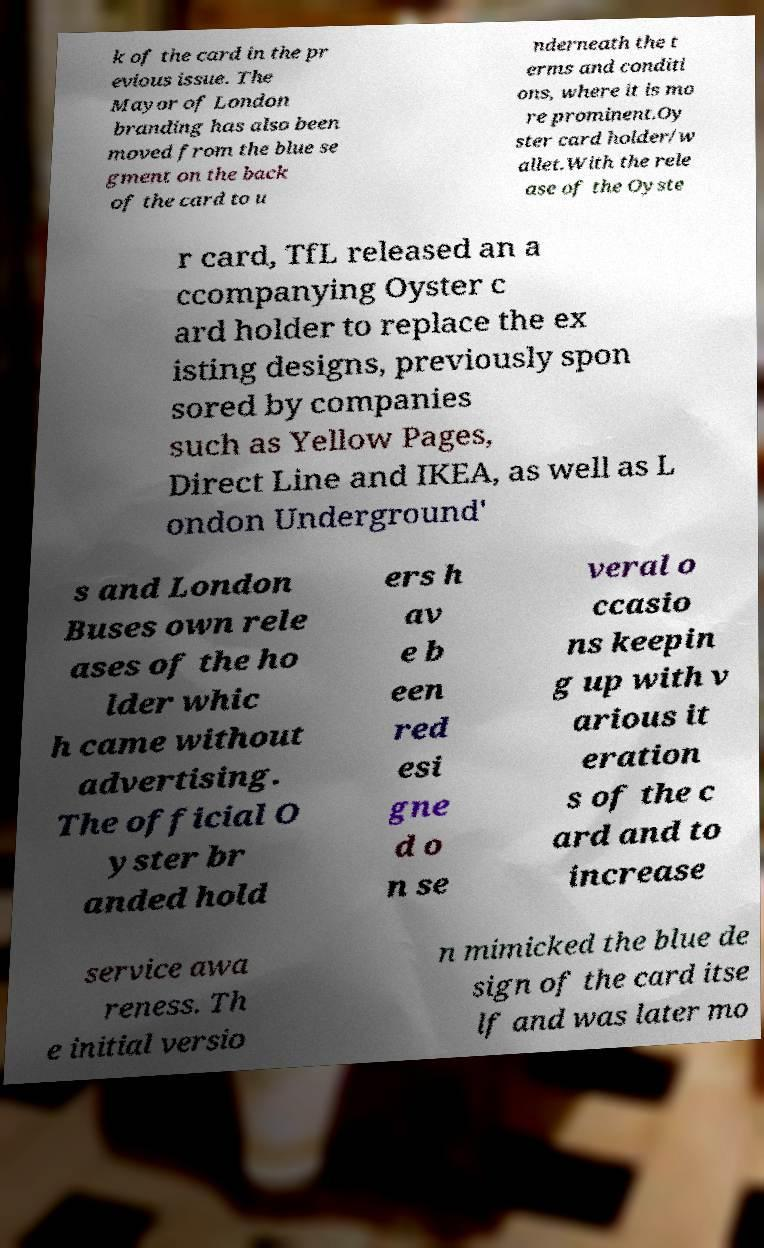Can you read and provide the text displayed in the image?This photo seems to have some interesting text. Can you extract and type it out for me? k of the card in the pr evious issue. The Mayor of London branding has also been moved from the blue se gment on the back of the card to u nderneath the t erms and conditi ons, where it is mo re prominent.Oy ster card holder/w allet.With the rele ase of the Oyste r card, TfL released an a ccompanying Oyster c ard holder to replace the ex isting designs, previously spon sored by companies such as Yellow Pages, Direct Line and IKEA, as well as L ondon Underground' s and London Buses own rele ases of the ho lder whic h came without advertising. The official O yster br anded hold ers h av e b een red esi gne d o n se veral o ccasio ns keepin g up with v arious it eration s of the c ard and to increase service awa reness. Th e initial versio n mimicked the blue de sign of the card itse lf and was later mo 